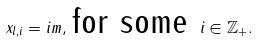Convert formula to latex. <formula><loc_0><loc_0><loc_500><loc_500>x _ { l , i } = i m , \, \text {for some } { i \in \mathbb { Z } _ { + } } .</formula> 